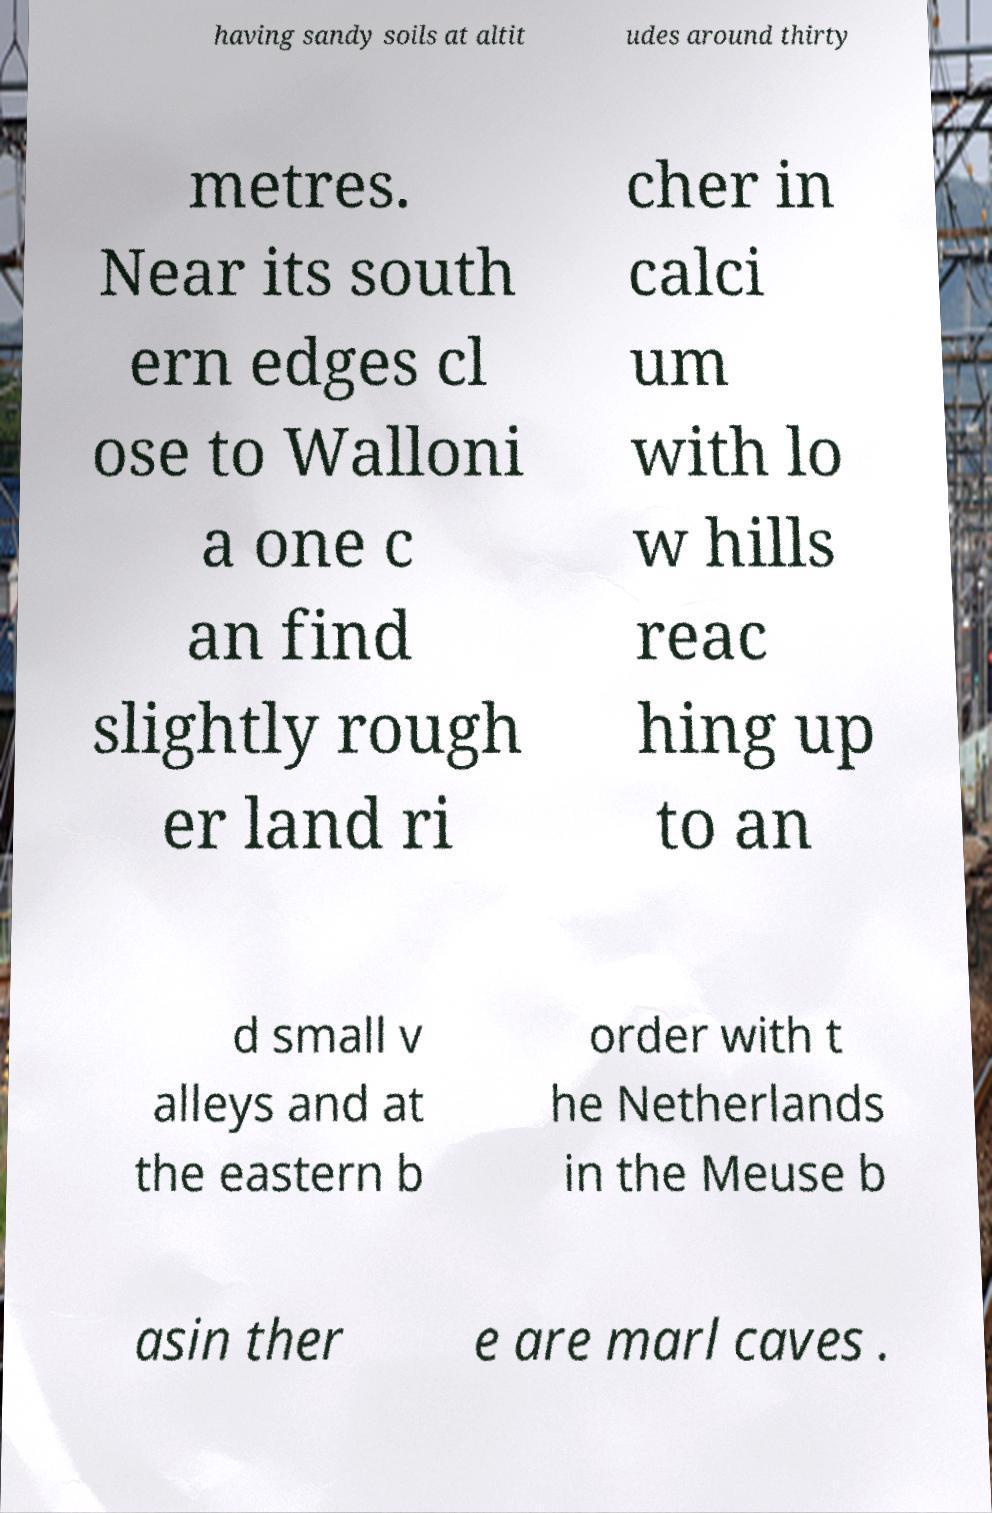Could you extract and type out the text from this image? having sandy soils at altit udes around thirty metres. Near its south ern edges cl ose to Walloni a one c an find slightly rough er land ri cher in calci um with lo w hills reac hing up to an d small v alleys and at the eastern b order with t he Netherlands in the Meuse b asin ther e are marl caves . 